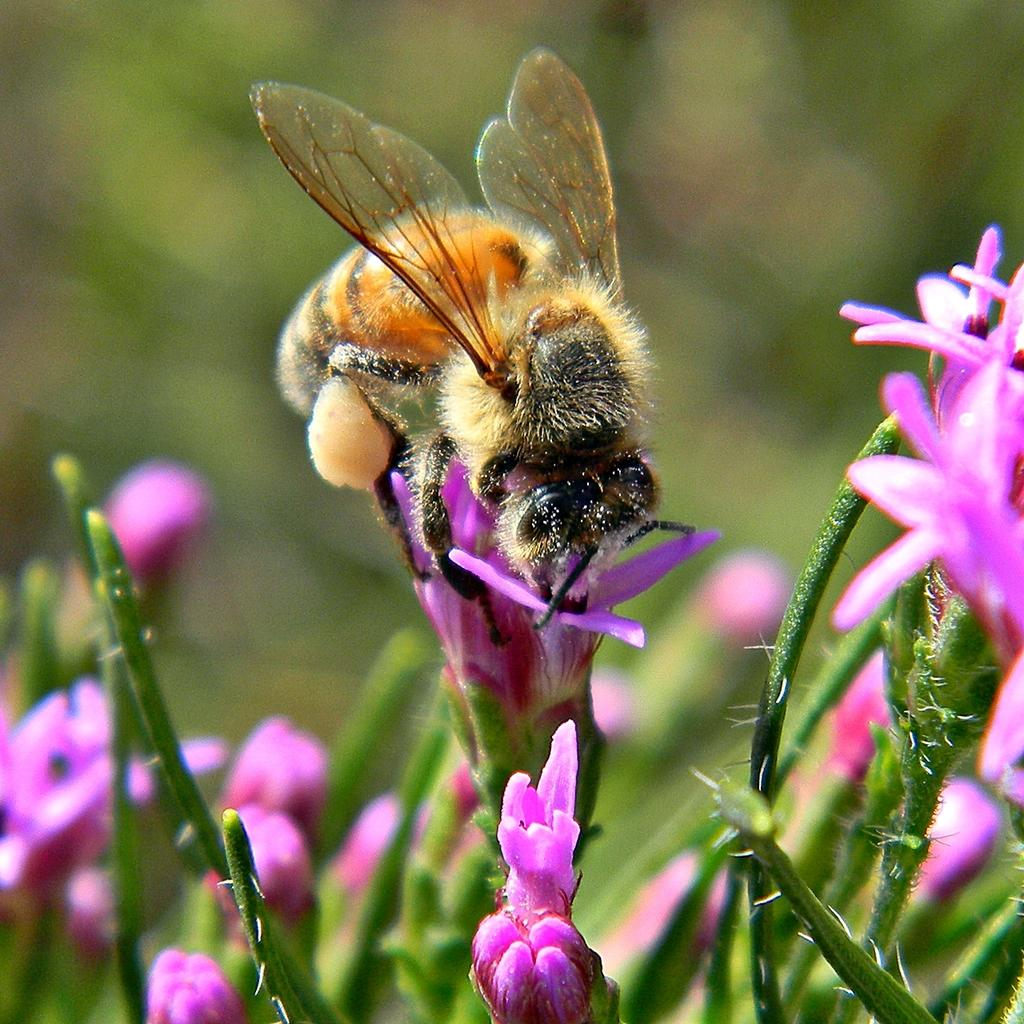What type of plants can be seen in the image? There are flowering plants in the image. Can you describe any specific interaction happening in the image? Yes, there is an insect on a flower in the image. What might be the location where the image was taken? The image may have been taken in a garden. What language is spoken by the insect in the image? Insects do not speak any language, so this question cannot be answered. 